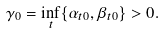Convert formula to latex. <formula><loc_0><loc_0><loc_500><loc_500>\gamma _ { 0 } = \inf _ { t } \{ \alpha _ { t 0 } , \beta _ { t 0 } \} > 0 .</formula> 